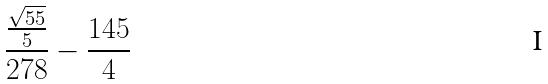<formula> <loc_0><loc_0><loc_500><loc_500>\frac { \frac { \sqrt { 5 5 } } { 5 } } { 2 7 8 } - \frac { 1 4 5 } { 4 }</formula> 